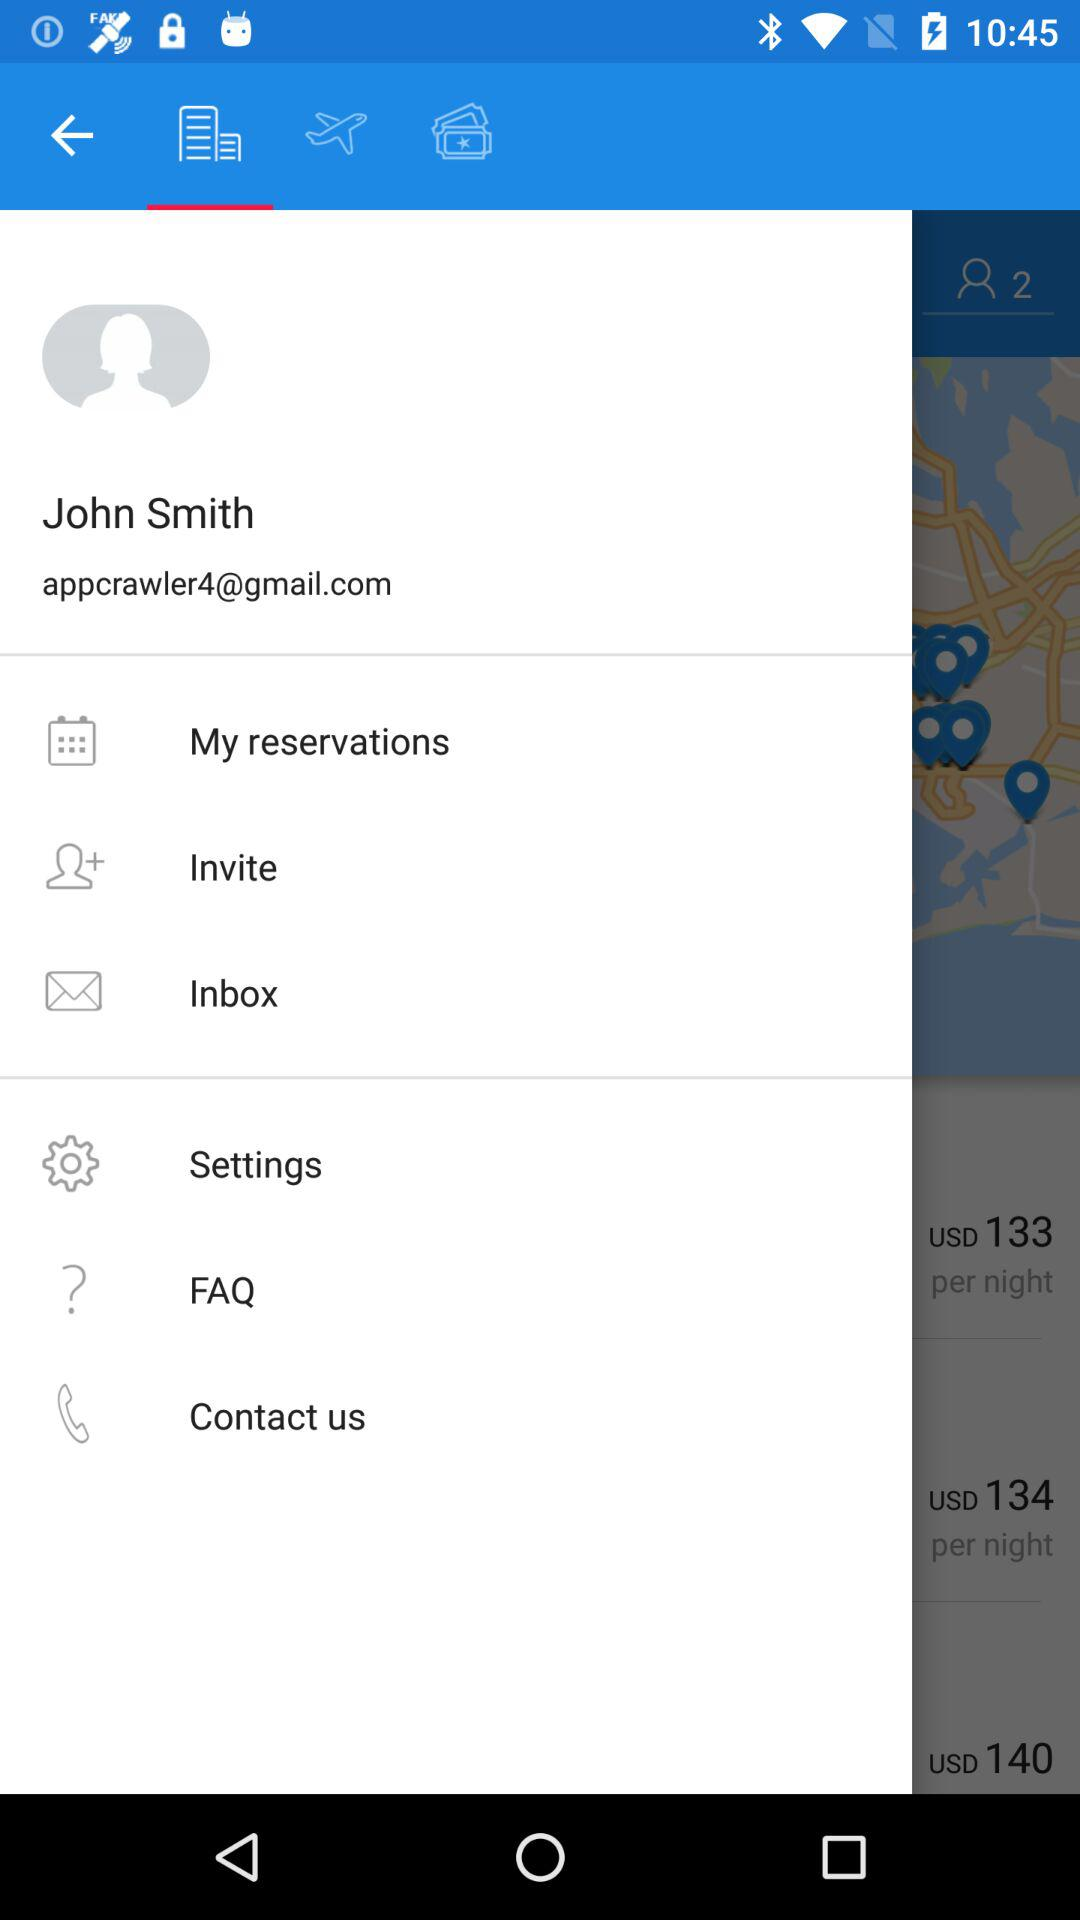Which tab is selected?
When the provided information is insufficient, respond with <no answer>. <no answer> 